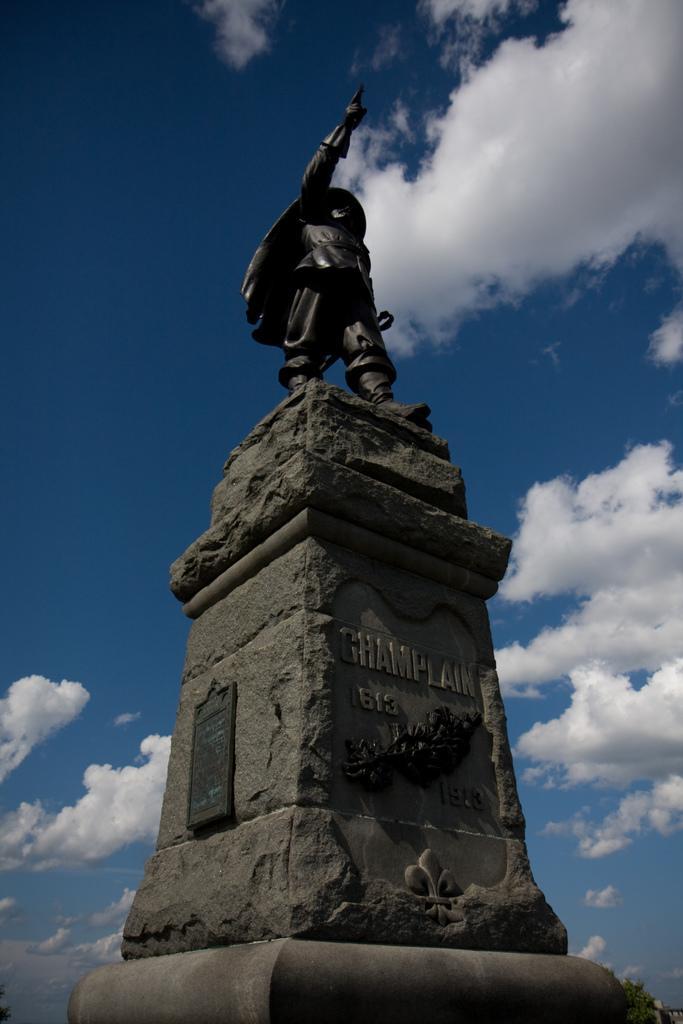Describe this image in one or two sentences. In the center of the image there is a statue. In the background there is a sky and clouds. 